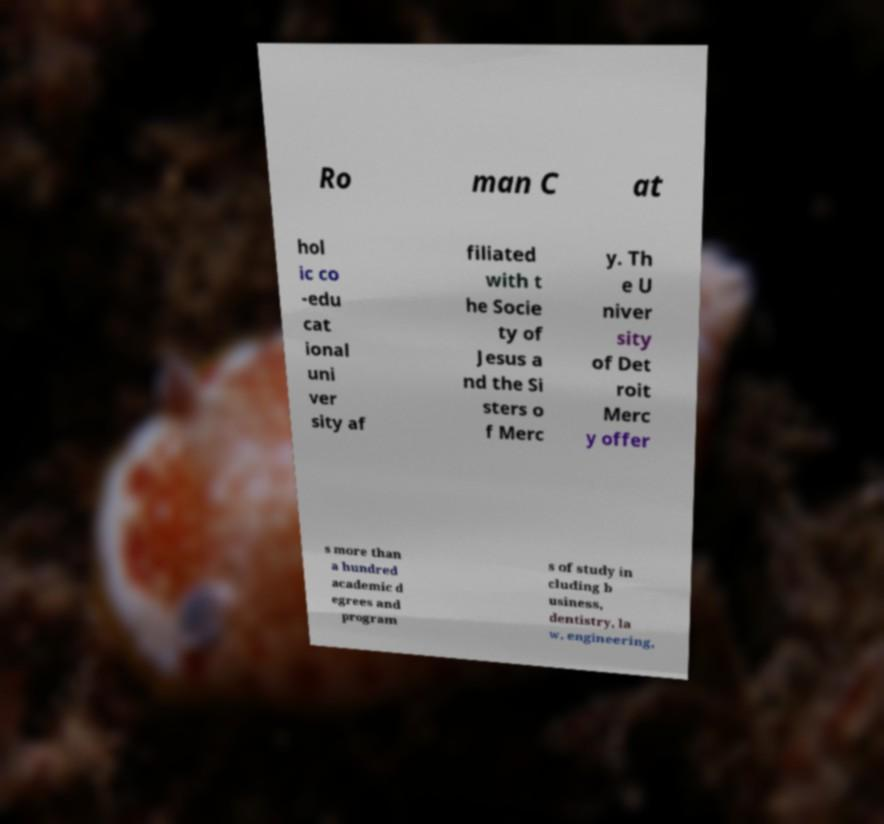For documentation purposes, I need the text within this image transcribed. Could you provide that? Ro man C at hol ic co -edu cat ional uni ver sity af filiated with t he Socie ty of Jesus a nd the Si sters o f Merc y. Th e U niver sity of Det roit Merc y offer s more than a hundred academic d egrees and program s of study in cluding b usiness, dentistry, la w, engineering, 